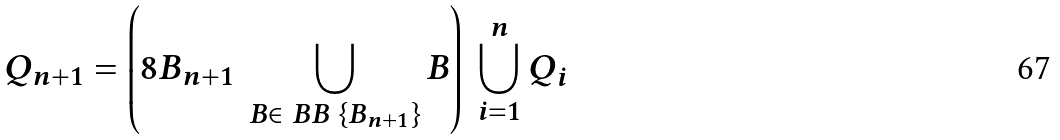<formula> <loc_0><loc_0><loc_500><loc_500>Q _ { n + 1 } = \left ( 8 B _ { n + 1 } \ \bigcup _ { B \in \ B B \ \{ B _ { n + 1 } \} } B \right ) \ \bigcup _ { i = 1 } ^ { n } Q _ { i }</formula> 